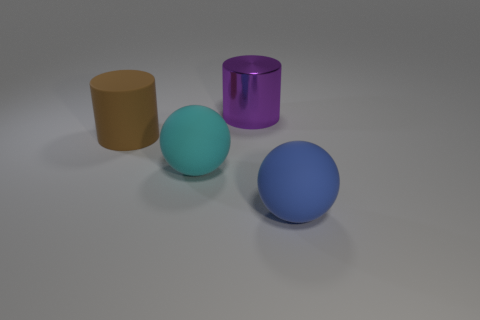Is the number of big cyan things that are in front of the large purple metal cylinder less than the number of large red rubber objects?
Provide a short and direct response. No. The object that is to the right of the thing behind the large cylinder to the left of the metal cylinder is what color?
Your response must be concise. Blue. What number of metal things are brown cylinders or large cylinders?
Provide a short and direct response. 1. Is the purple object the same size as the cyan object?
Offer a terse response. Yes. Is the number of big blue matte things to the left of the purple object less than the number of balls behind the blue sphere?
Your response must be concise. Yes. Is there any other thing that is the same size as the purple metallic cylinder?
Provide a short and direct response. Yes. How big is the purple cylinder?
Ensure brevity in your answer.  Large. What number of big things are either brown rubber cylinders or matte things?
Provide a short and direct response. 3. Does the brown rubber object have the same size as the cyan rubber object that is to the left of the large purple thing?
Make the answer very short. Yes. Is there anything else that is the same shape as the purple shiny thing?
Your response must be concise. Yes. 